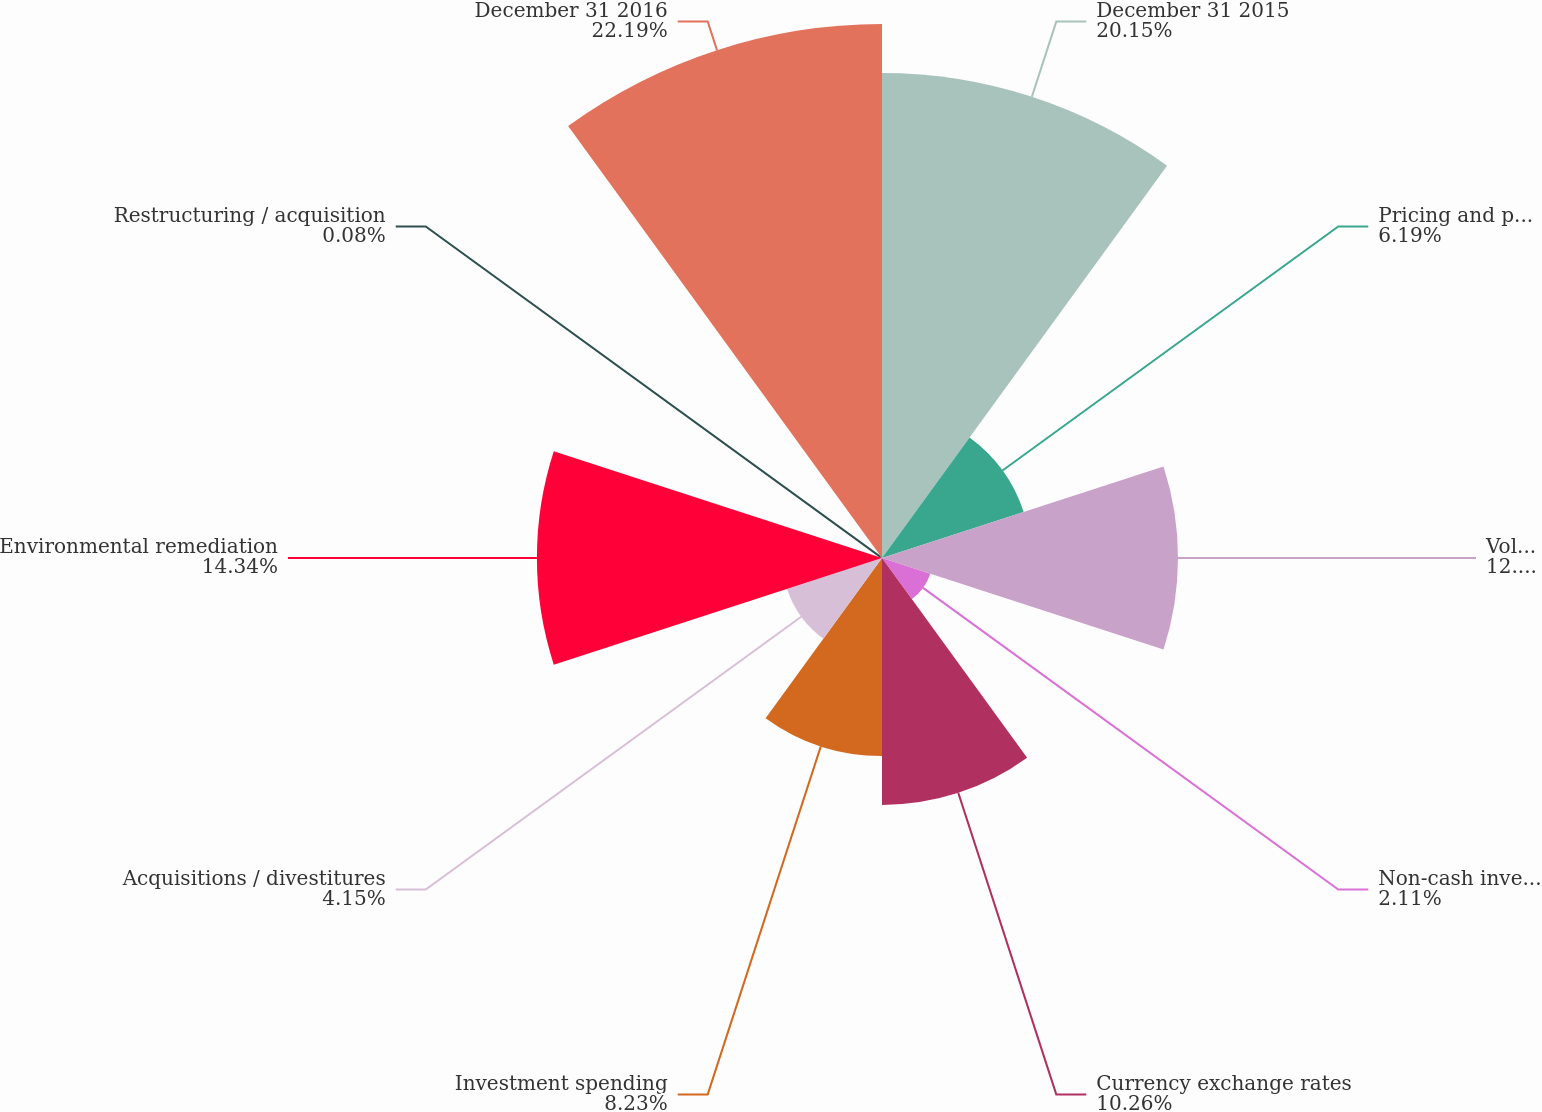Convert chart. <chart><loc_0><loc_0><loc_500><loc_500><pie_chart><fcel>December 31 2015<fcel>Pricing and productivity in<fcel>Volume / Product mix<fcel>Non-cash inventory impairment<fcel>Currency exchange rates<fcel>Investment spending<fcel>Acquisitions / divestitures<fcel>Environmental remediation<fcel>Restructuring / acquisition<fcel>December 31 2016<nl><fcel>20.15%<fcel>6.19%<fcel>12.3%<fcel>2.11%<fcel>10.26%<fcel>8.23%<fcel>4.15%<fcel>14.34%<fcel>0.08%<fcel>22.19%<nl></chart> 